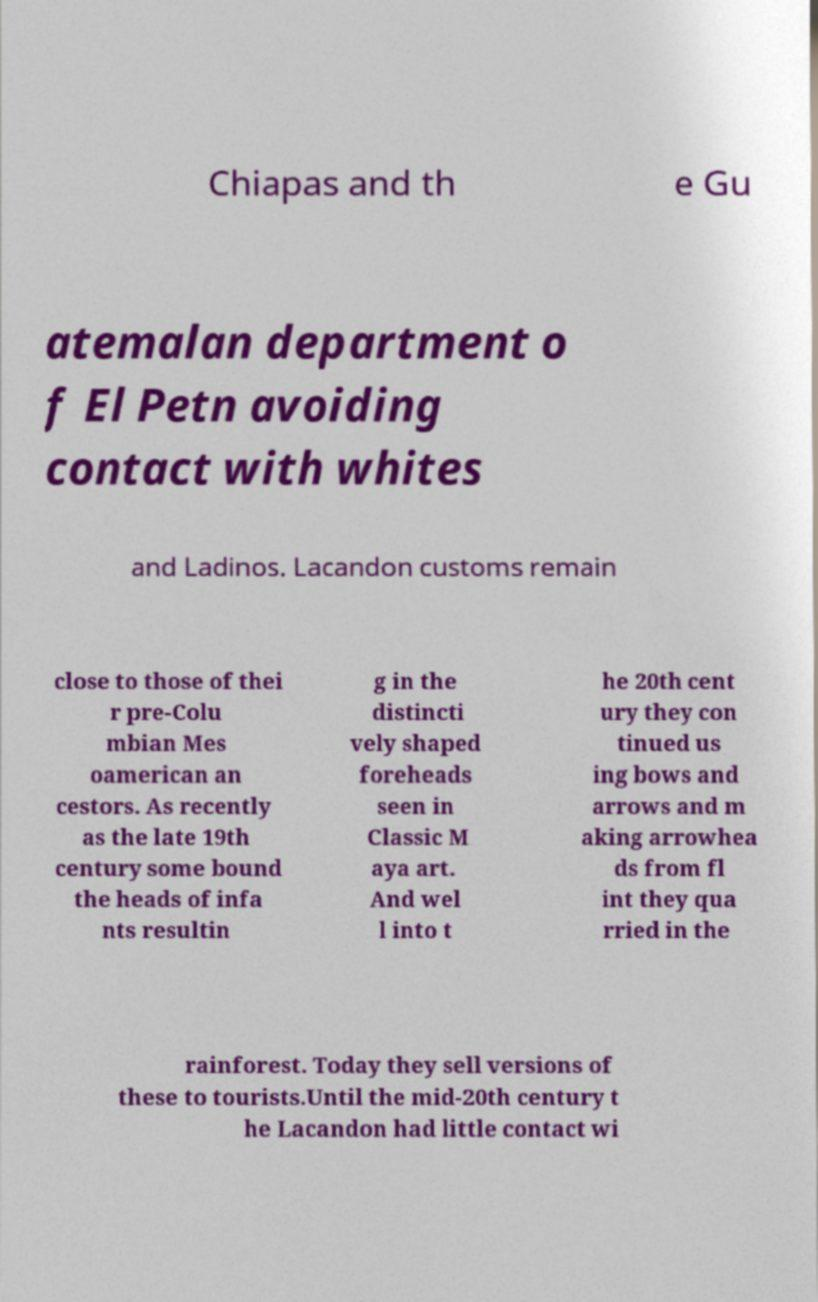What messages or text are displayed in this image? I need them in a readable, typed format. Chiapas and th e Gu atemalan department o f El Petn avoiding contact with whites and Ladinos. Lacandon customs remain close to those of thei r pre-Colu mbian Mes oamerican an cestors. As recently as the late 19th century some bound the heads of infa nts resultin g in the distincti vely shaped foreheads seen in Classic M aya art. And wel l into t he 20th cent ury they con tinued us ing bows and arrows and m aking arrowhea ds from fl int they qua rried in the rainforest. Today they sell versions of these to tourists.Until the mid-20th century t he Lacandon had little contact wi 